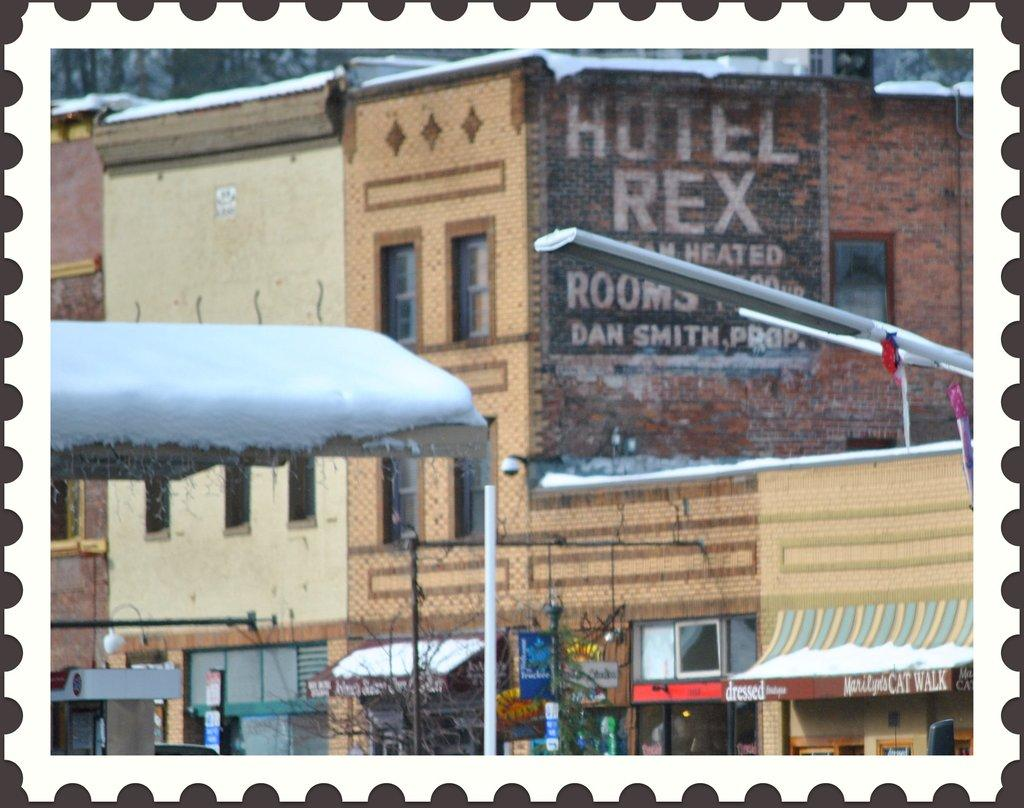What type of structures can be seen in the image? There are buildings in the image. What is located in front of the buildings? There are shops in front of the buildings. What type of lighting is present in front of the shops? There are lamp posts in front of the shops. Are there any security measures visible in the image? Yes, CCTVs are present in the image. What type of vegetation can be seen in the image? Trees are visible in the image. Can you see any ghosts swimming in the sand in the image? No, there are no ghosts, swimming, or sand present in the image. 